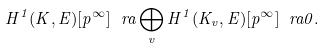Convert formula to latex. <formula><loc_0><loc_0><loc_500><loc_500>H ^ { 1 } ( K , E ) [ p ^ { \infty } ] \ r a \bigoplus _ { v } H ^ { 1 } ( K _ { v } , E ) [ p ^ { \infty } ] \ r a 0 .</formula> 